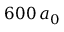Convert formula to latex. <formula><loc_0><loc_0><loc_500><loc_500>6 0 0 \, a _ { 0 }</formula> 